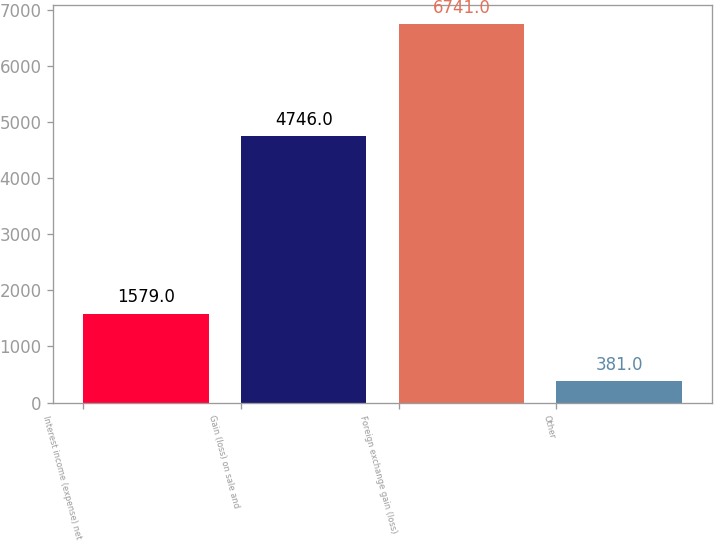<chart> <loc_0><loc_0><loc_500><loc_500><bar_chart><fcel>Interest income (expense) net<fcel>Gain (loss) on sale and<fcel>Foreign exchange gain (loss)<fcel>Other<nl><fcel>1579<fcel>4746<fcel>6741<fcel>381<nl></chart> 